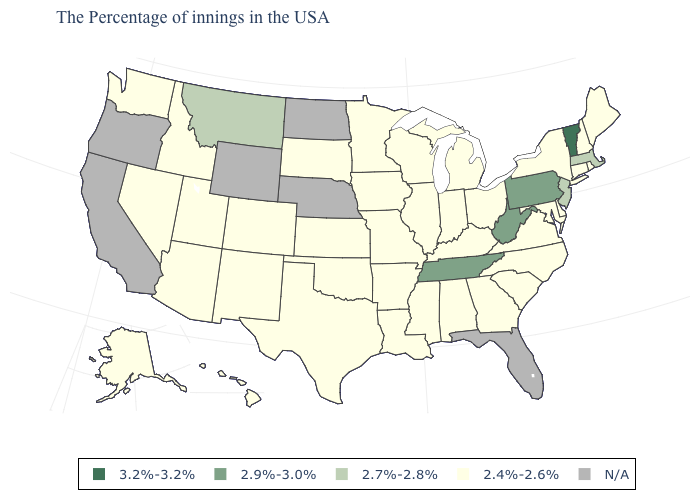What is the lowest value in the USA?
Write a very short answer. 2.4%-2.6%. Name the states that have a value in the range 2.4%-2.6%?
Answer briefly. Maine, Rhode Island, New Hampshire, Connecticut, New York, Delaware, Maryland, Virginia, North Carolina, South Carolina, Ohio, Georgia, Michigan, Kentucky, Indiana, Alabama, Wisconsin, Illinois, Mississippi, Louisiana, Missouri, Arkansas, Minnesota, Iowa, Kansas, Oklahoma, Texas, South Dakota, Colorado, New Mexico, Utah, Arizona, Idaho, Nevada, Washington, Alaska, Hawaii. Among the states that border North Dakota , which have the highest value?
Quick response, please. Montana. Does the first symbol in the legend represent the smallest category?
Be succinct. No. Does Missouri have the lowest value in the USA?
Quick response, please. Yes. Does the first symbol in the legend represent the smallest category?
Concise answer only. No. Among the states that border North Carolina , which have the highest value?
Give a very brief answer. Tennessee. Name the states that have a value in the range 3.2%-3.2%?
Give a very brief answer. Vermont. What is the value of Oklahoma?
Give a very brief answer. 2.4%-2.6%. Which states have the lowest value in the USA?
Short answer required. Maine, Rhode Island, New Hampshire, Connecticut, New York, Delaware, Maryland, Virginia, North Carolina, South Carolina, Ohio, Georgia, Michigan, Kentucky, Indiana, Alabama, Wisconsin, Illinois, Mississippi, Louisiana, Missouri, Arkansas, Minnesota, Iowa, Kansas, Oklahoma, Texas, South Dakota, Colorado, New Mexico, Utah, Arizona, Idaho, Nevada, Washington, Alaska, Hawaii. Name the states that have a value in the range 2.7%-2.8%?
Give a very brief answer. Massachusetts, New Jersey, Montana. Among the states that border Missouri , does Tennessee have the lowest value?
Concise answer only. No. 